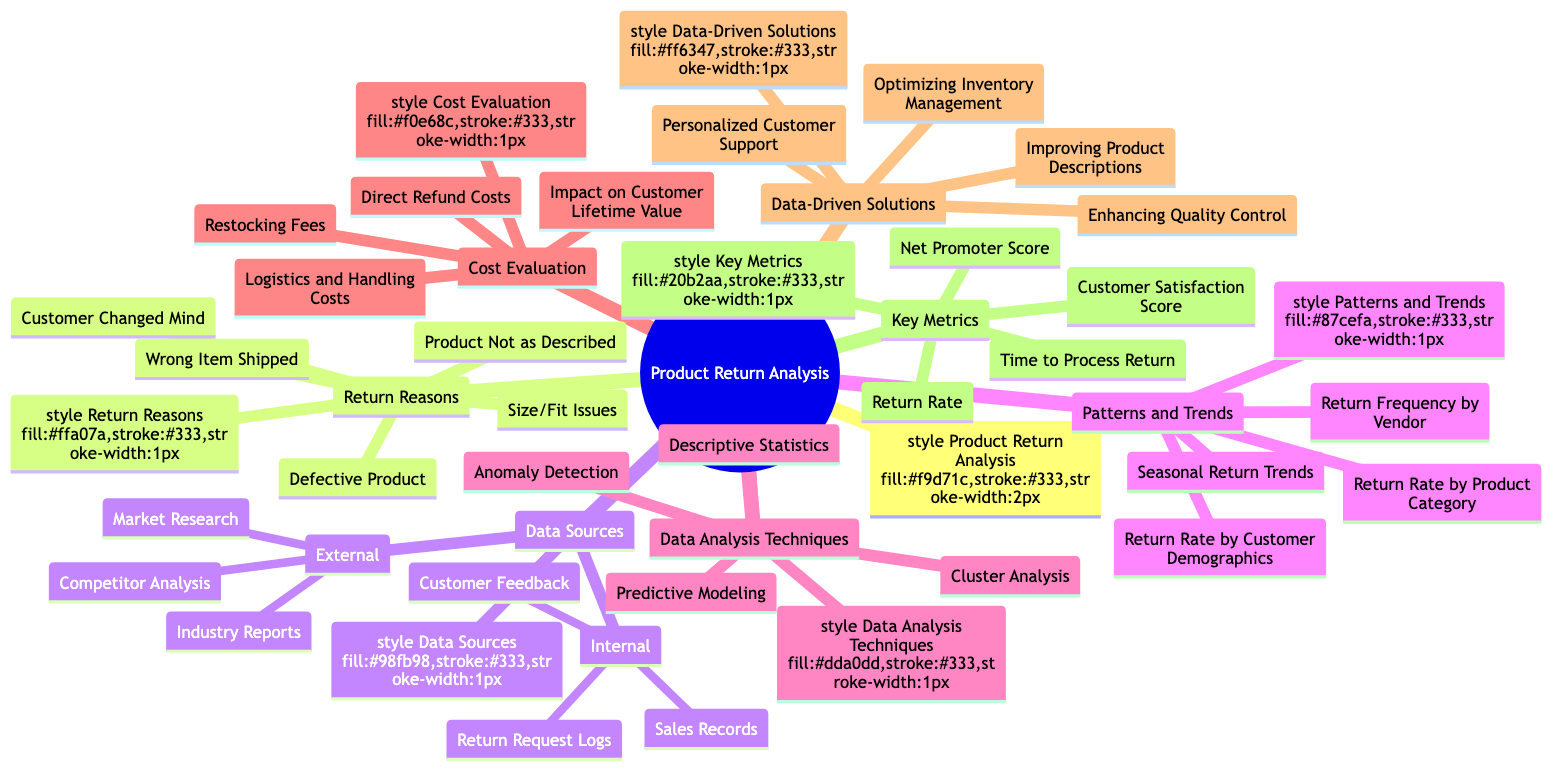What are the return reasons listed in the diagram? The diagram contains a category titled "Return Reasons" which lists five specific reasons for product returns: Defective Product, Wrong Item Shipped, Customer Changed Mind, Product Not as Described, and Size/Fit Issues.
Answer: Defective Product, Wrong Item Shipped, Customer Changed Mind, Product Not as Described, Size/Fit Issues How many internal data sources are mentioned? Under the category "Data Sources," there are two subcategories: Internal and External. The Internal category lists three sources: Sales Records, Customer Feedback, and Return Request Logs. Thus, there are a total of three internal data sources mentioned in the diagram.
Answer: 3 What is one method used for data analysis? In the "Data Analysis Techniques" category, the diagram presents four methods, one of which is Descriptive Statistics. Since the question asks for any method, Descriptive Statistics can be cited as the answer.
Answer: Descriptive Statistics What impact does the cost evaluation have? The "Cost Evaluation" category lists multiple cost aspects related to returns, including Direct Refund Costs, Logistics and Handling Costs, Restocking Fees, and Impact on Customer Lifetime Value. The question aims to understand the Area's overall impact, which encompasses evaluating how these costs affect profitability and customer engagement, highlighting the interconnected nature of these elements.
Answer: Costs affect profitability and customer engagement What is the relationship between "Data-Driven Solutions" and "Improving Product Descriptions"? "Improving Product Descriptions" is listed as one of the solutions under the "Data-Driven Solutions" category which shares a direct relationship with analyzing return reasons and customer satisfaction. This connection indicates that enhancing descriptions might directly mitigate returns due to inaccuracies, highlighting how data analysis can lead to actionable solutions.
Answer: Improving descriptions reduces return reasons Which category includes the metric "Customer Satisfaction Score"? The "Key Metrics" category is where "Customer Satisfaction Score" is mentioned among other important metrics. Thus, this category directly answers which part of the diagram includes this specific metric.
Answer: Key Metrics Which analysis technique focuses on outlier detection? The "Data Analysis Techniques" category contains "Anomaly Detection" as one of the four techniques listed. Anomaly Detection specifically pertains to identifying outlier data points that deviate from expected patterns, qualifying it as the technique focused on outlier detection.
Answer: Anomaly Detection How many return patterns are identified? The "Patterns and Trends" section in the diagram lists four specific patterns: Return Rate by Product Category, Return Rate by Customer Demographics, Seasonal Return Trends, and Return Frequency by Vendor. Therefore, it indicates that there are four distinct return patterns identified in the analysis.
Answer: 4 